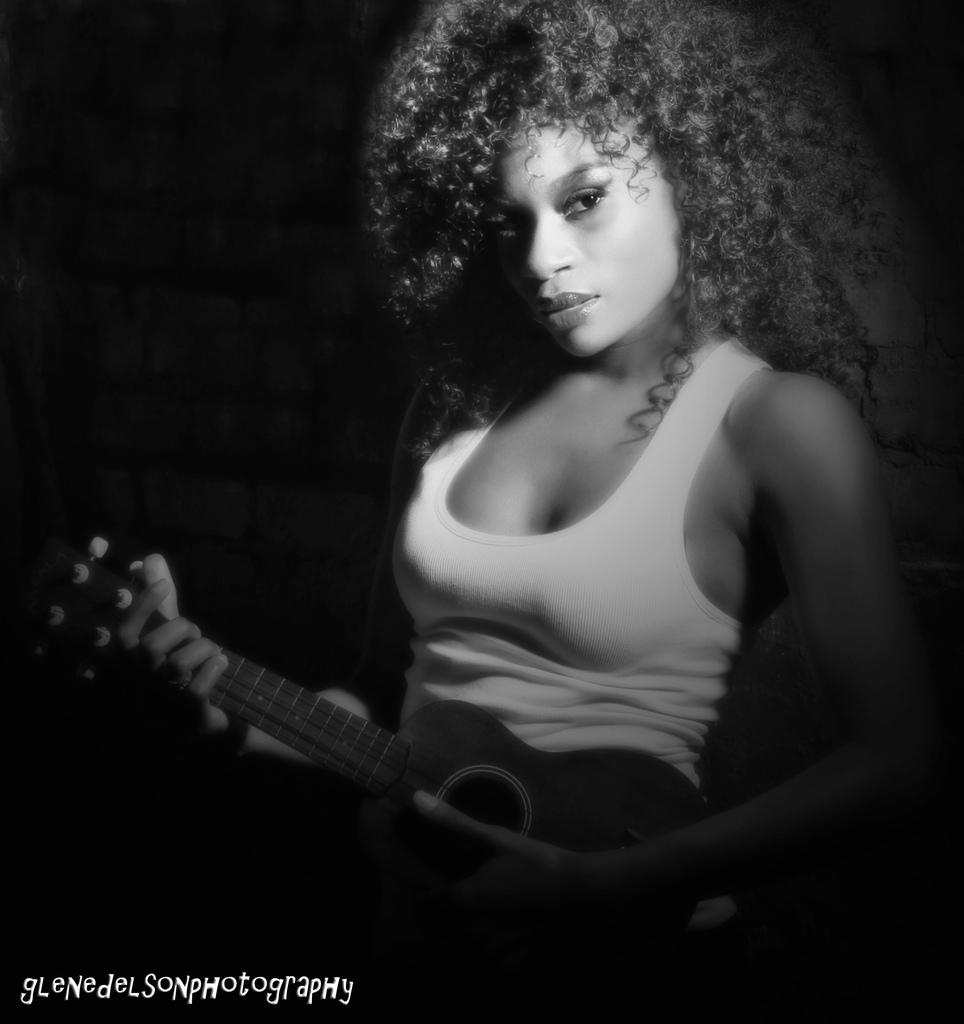What is the main subject of the image? The main subject of the image is a woman. Can you describe the woman's hair in the image? The woman has curly hair. What is the woman holding in her hand in the image? The woman is holding a musical instrument in her hand. What type of oven can be seen in the background of the image? There is no oven present in the image. Can you describe the pig that is accompanying the woman in the image? There is no pig present in the image. 